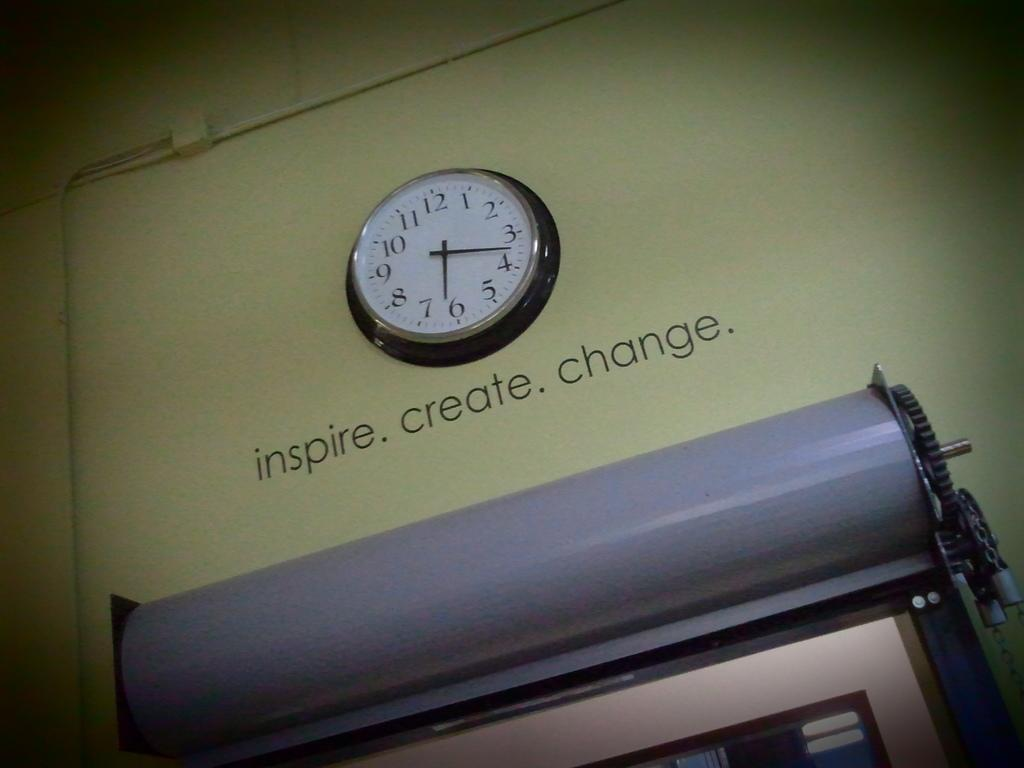<image>
Offer a succinct explanation of the picture presented. A black and white clock on the wall with the words inspire, create and change underneath the clock. 